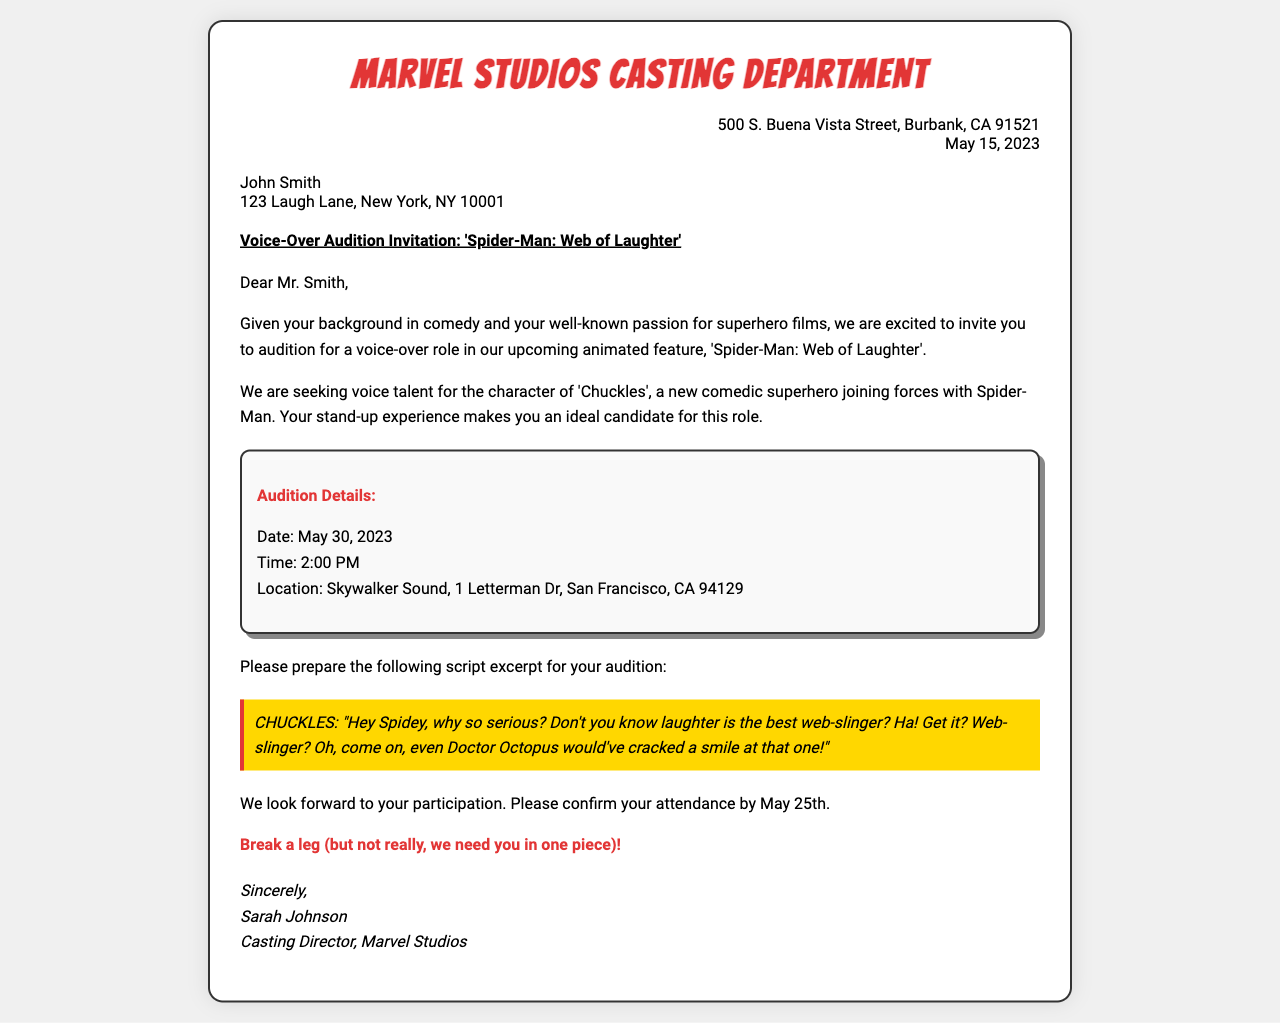What is the title of the animated feature? The title of the animated feature is explicitly stated in the subject line of the document as 'Spider-Man: Web of Laughter'.
Answer: Spider-Man: Web of Laughter Who is the casting director? The casting director's name is mentioned at the bottom of the document where it says "Sincerely, Sarah Johnson".
Answer: Sarah Johnson What character is being auditioned for? The character being auditioned for is specified in the body of the document as 'Chuckles'.
Answer: Chuckles What is the audition date? The audition date can be found in the audition details section and is clearly listed as May 30, 2023.
Answer: May 30, 2023 Where is the recording studio located? The location of the recording studio is mentioned in the audition details section as "Skywalker Sound, 1 Letterman Dr, San Francisco, CA 94129".
Answer: Skywalker Sound, 1 Letterman Dr, San Francisco, CA 94129 Why was John Smith invited to audition? The document states that John Smith was invited to audition because of his background in comedy and passion for superhero films.
Answer: Comedy background and superhero passion What time is the audition scheduled for? The audition time is included in the audition details section, stated as 2:00 PM.
Answer: 2:00 PM By when should John Smith confirm his attendance? The deadline for confirmation is mentioned in the body of the document as May 25th.
Answer: May 25th What is Chuckles' line in the script excerpt? The specific line for Chuckles during the audition is presented in the script excerpt section as "Hey Spidey, why so serious? Don't you know laughter is the best web-slinger? Ha! Get it? Web-slinger? Oh, come on, even Doctor Octopus would've cracked a smile at that one!"
Answer: "Hey Spidey, why so serious? Don't you know laughter is the best web-slinger? Ha! Get it? Web-slinger? Oh, come on, even Doctor Octopus would've cracked a smile at that one!" 